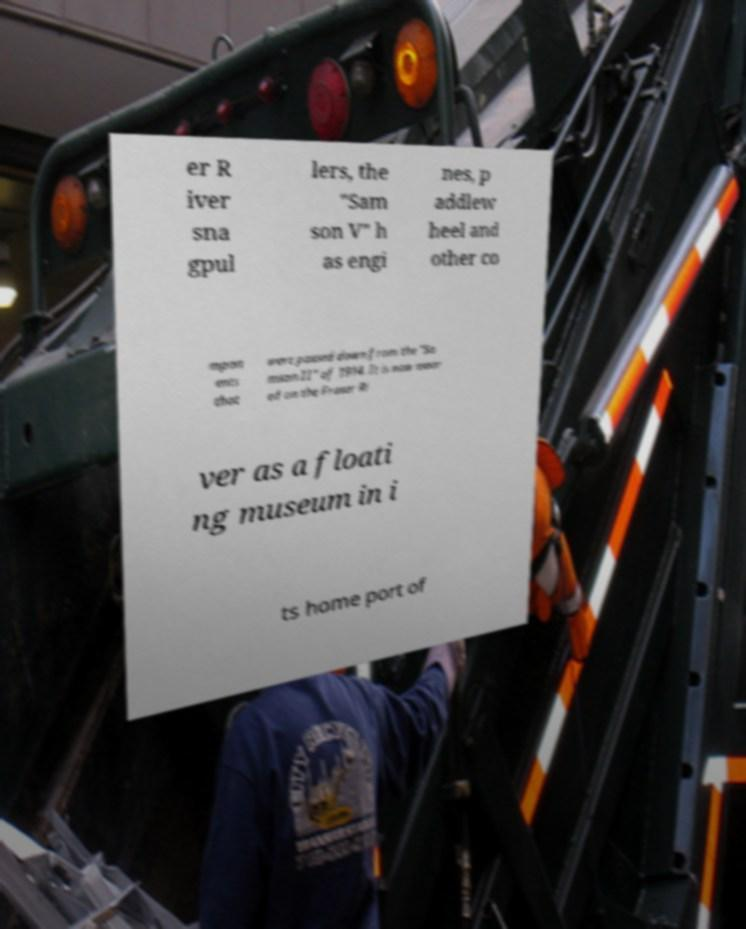There's text embedded in this image that I need extracted. Can you transcribe it verbatim? er R iver sna gpul lers, the "Sam son V" h as engi nes, p addlew heel and other co mpon ents that were passed down from the "Sa mson II" of 1914. It is now moor ed on the Fraser Ri ver as a floati ng museum in i ts home port of 